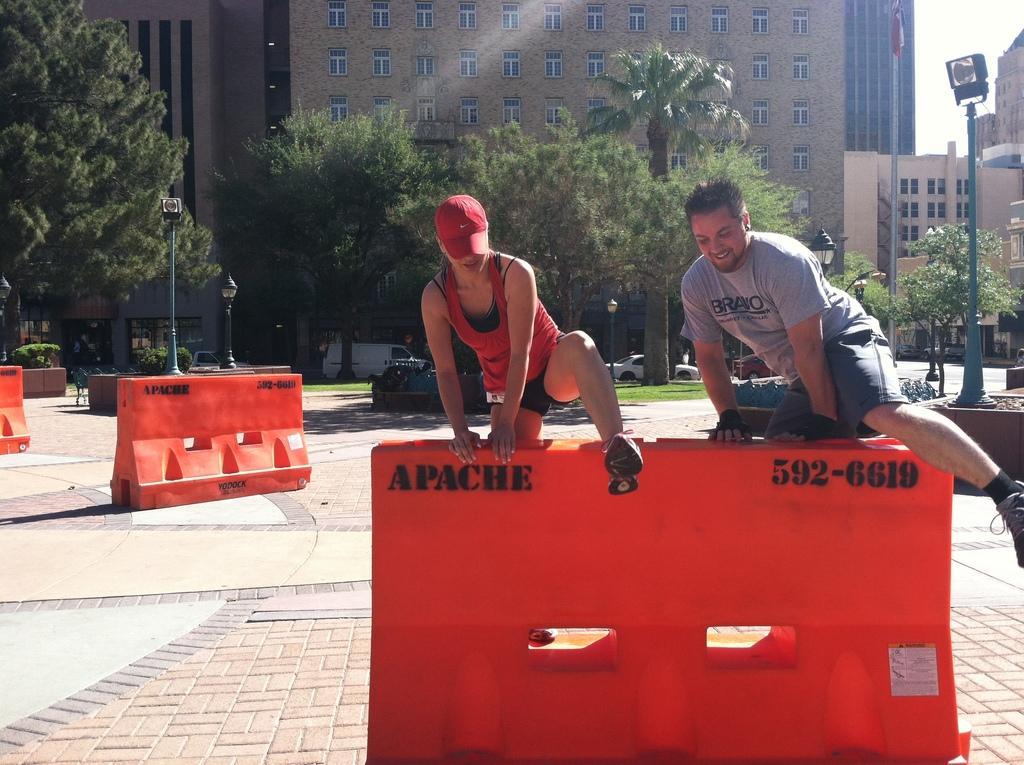Could you give a brief overview of what you see in this image? In the foreground of the image there are two persons jumping a barricade. In the background of the image there are buildings,trees. At the bottom of the image there is floor. To the right side of the image there is a pole. There is a flagpole. 